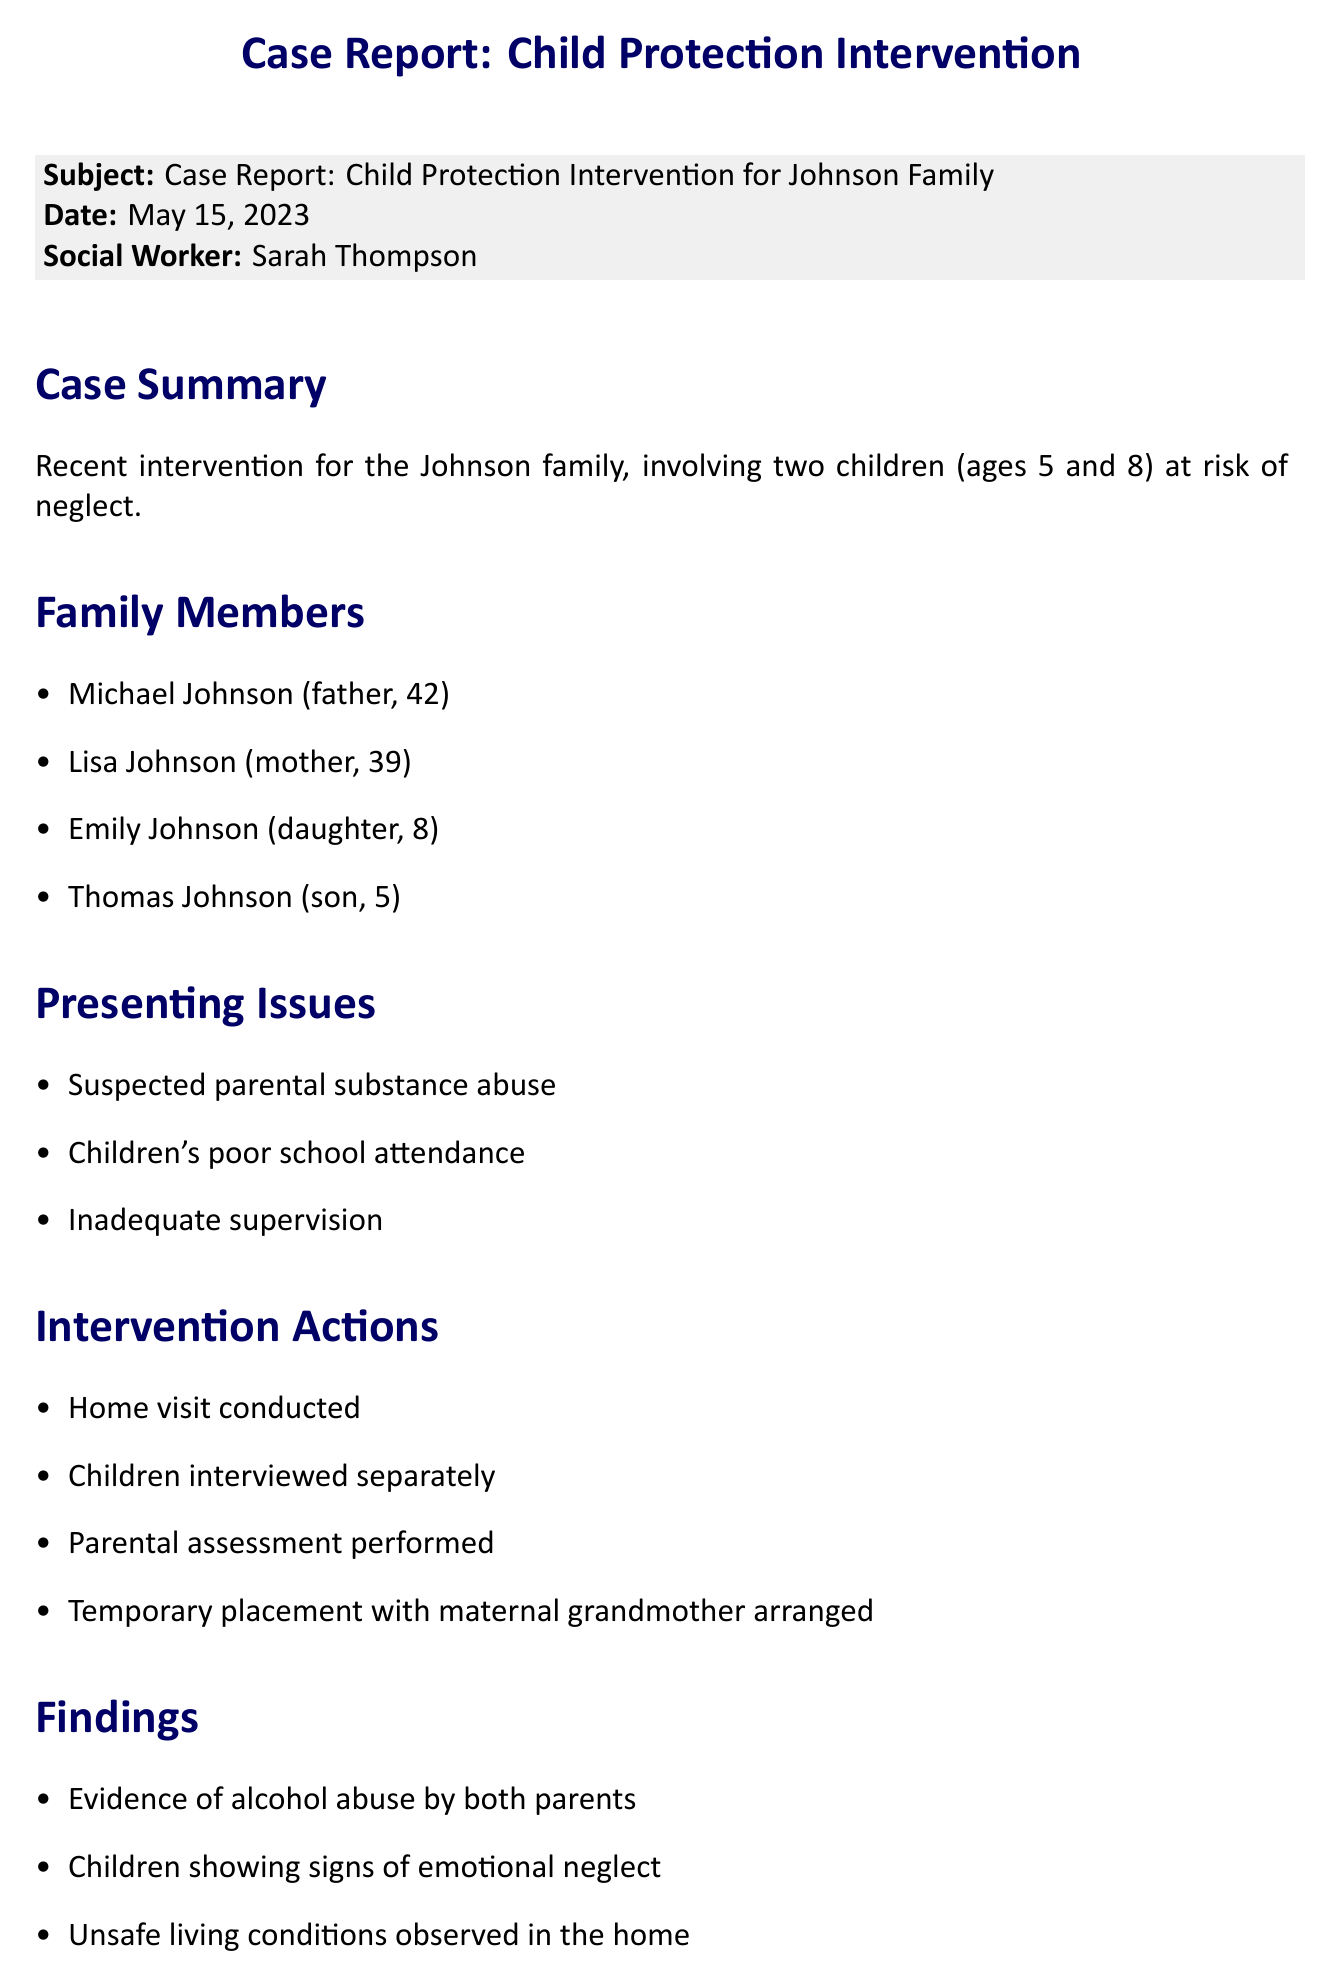What are the ages of the children involved? The document states that the children are 5 and 8 years old.
Answer: 5 and 8 Who conducted the home visit? According to the document, Sarah Thompson is the social worker who conducted the intervention actions.
Answer: Sarah Thompson What was arranged for the children? The document mentions that a temporary placement with the maternal grandmother was arranged.
Answer: Temporary placement with maternal grandmother What findings were observed in the home? The findings included evidence of alcohol abuse by both parents and unsafe living conditions.
Answer: Unsafe living conditions What is the next visit date? The document specifies that the next visit is scheduled for June 1, 2023.
Answer: June 1, 2023 What are the key objectives of the follow-up plan? The document lists three objectives: assess parents' progress, evaluate children's adjustment, and coordinate with the school.
Answer: Assess parents' progress, evaluate children's adjustment, coordinate with school What is one recommendation for the parents? The document recommends mandatory substance abuse treatment for both parents.
Answer: Mandatory substance abuse treatment How many children are involved in the case? The document indicates that there are two children involved in the Johnson family case.
Answer: Two 